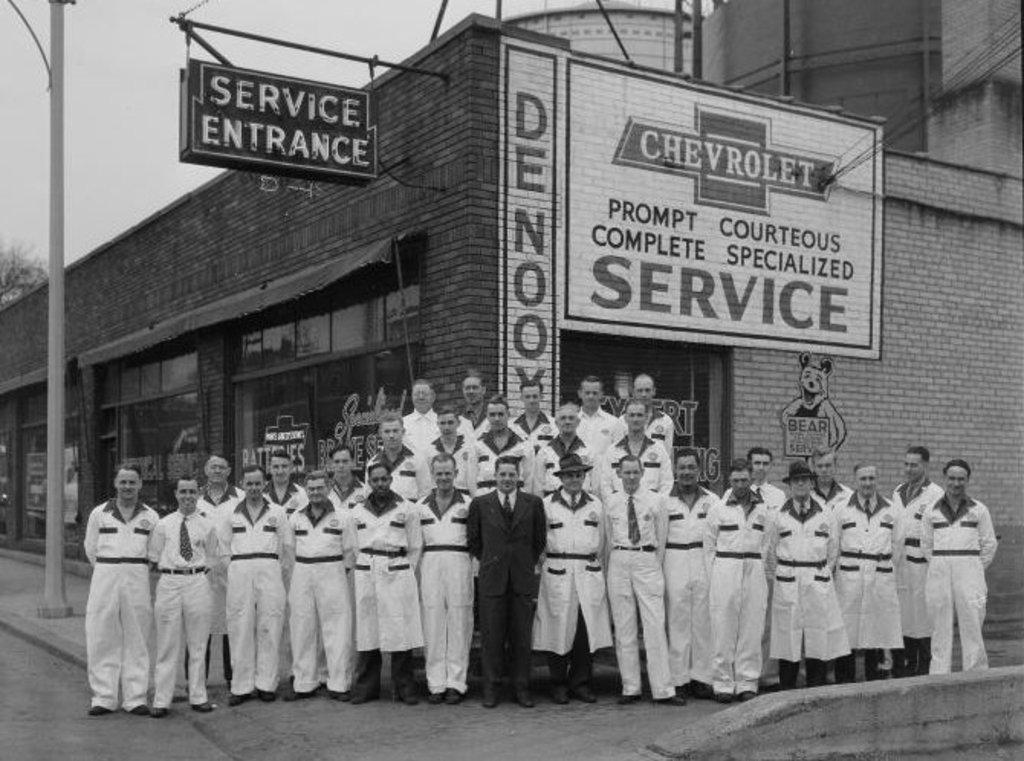Describe this image in one or two sentences. This is a black and white image. In this image we can see persons standing on the floor, stores, advertisement on the wall, sign board, name board, poles and sky. 